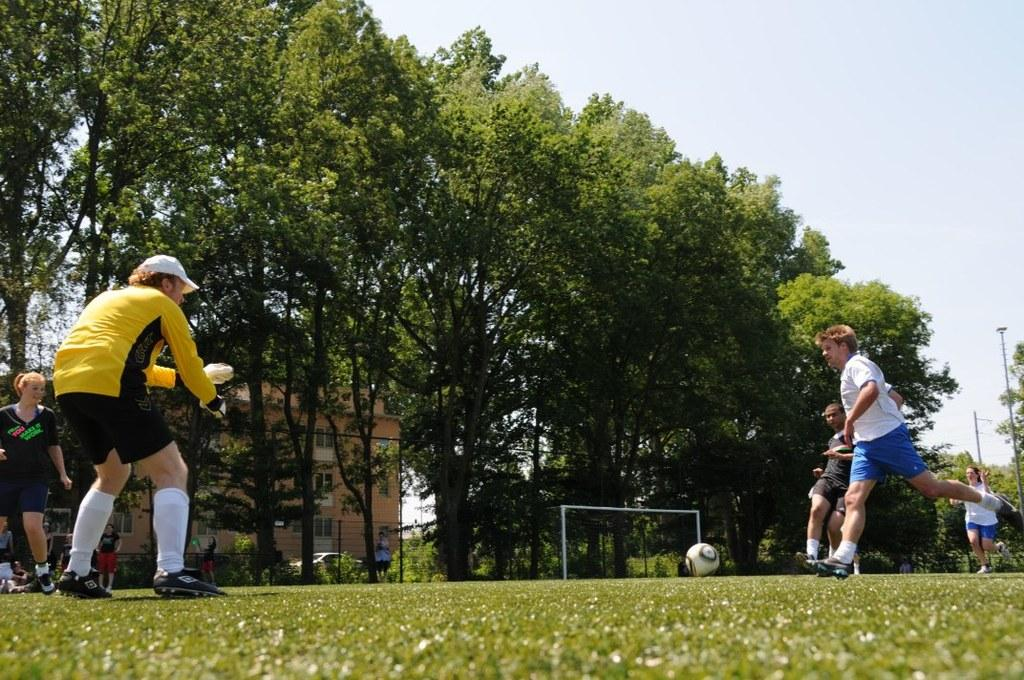What activity are the people in the image engaged in? The people in the image are playing with a ball. Where are the people playing with the ball? The people are on the ground. What type of natural vegetation can be seen in the image? There are trees in the image. How widespread are the trees in the area? The trees are all over the area. What structure is visible behind the trees? There is a building behind the trees. What is visible at the top of the image? The sky is visible at the top of the image. What type of account is being discussed by the people playing with the ball in the image? There is no mention of an account or any discussion in the image; it simply shows people playing with a ball. What color is the light emitted by the trees in the image? Trees do not emit light, so this question cannot be answered based on the information provided. 